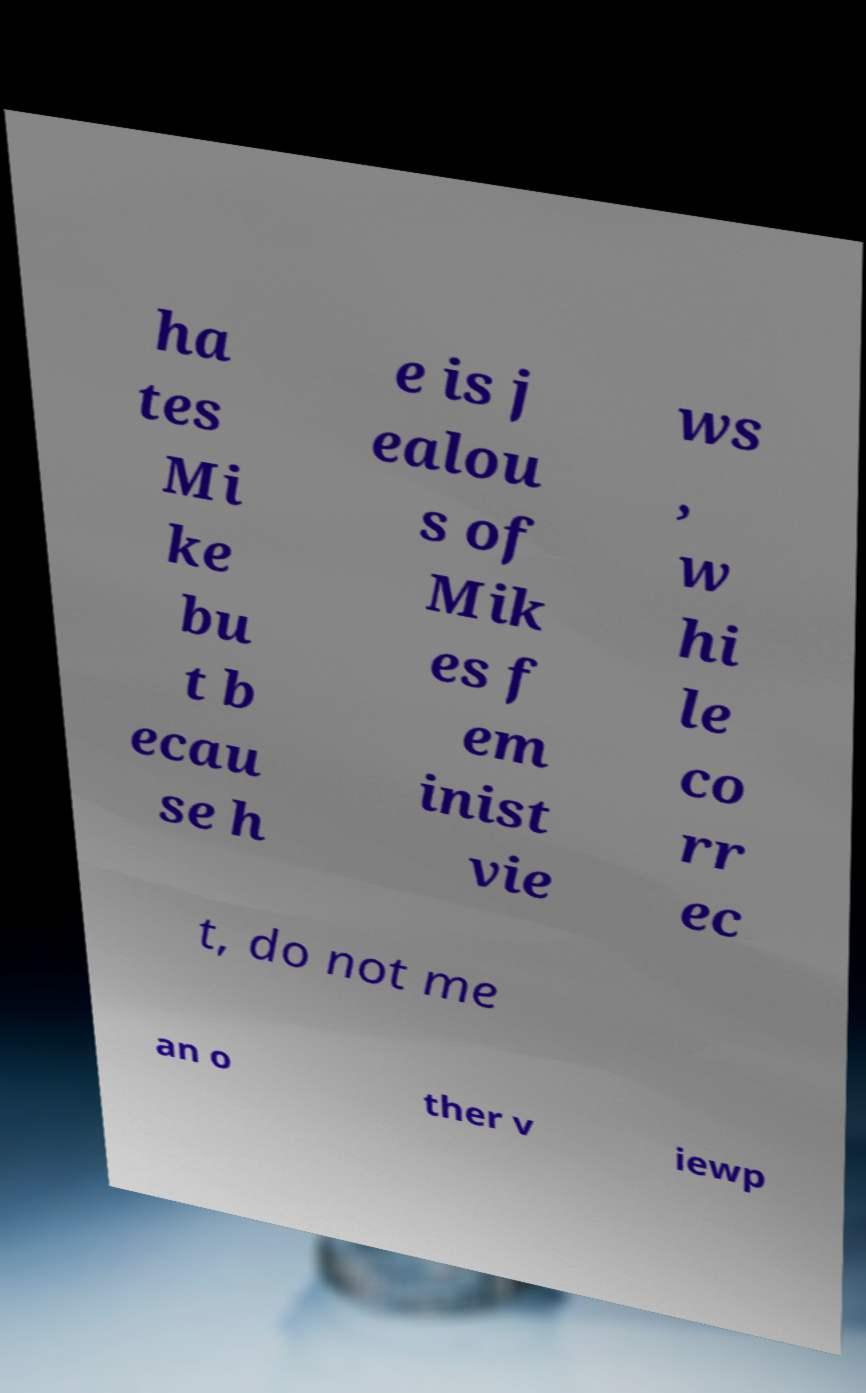For documentation purposes, I need the text within this image transcribed. Could you provide that? ha tes Mi ke bu t b ecau se h e is j ealou s of Mik es f em inist vie ws , w hi le co rr ec t, do not me an o ther v iewp 